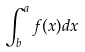Convert formula to latex. <formula><loc_0><loc_0><loc_500><loc_500>\int _ { b } ^ { a } f ( x ) d x</formula> 